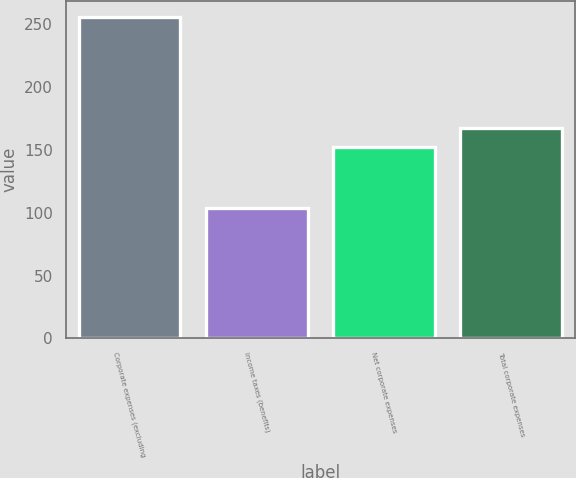Convert chart to OTSL. <chart><loc_0><loc_0><loc_500><loc_500><bar_chart><fcel>Corporate expenses (excluding<fcel>Income taxes (benefits)<fcel>Net corporate expenses<fcel>Total corporate expenses<nl><fcel>256<fcel>104<fcel>152<fcel>167.2<nl></chart> 